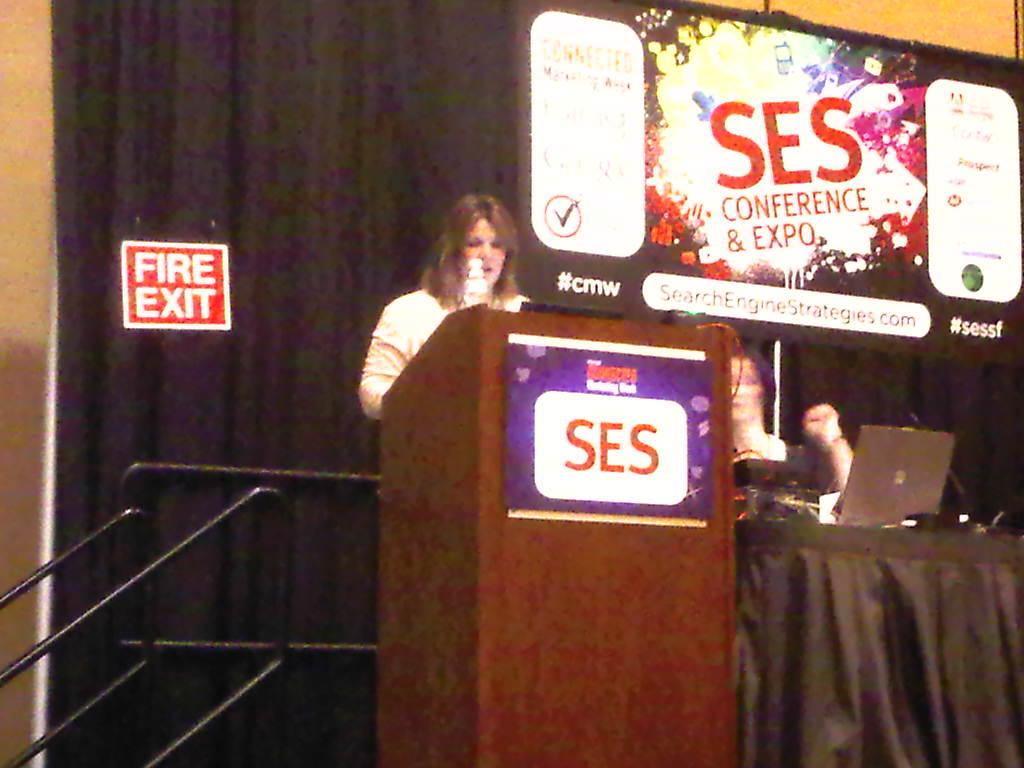In one or two sentences, can you explain what this image depicts? In this picture there is a lady who is standing in the center of the image in front of a wooden desk and there is a staircase on the left side of the image, there is a table on the right side of the image, on which there is a laptop and there is a another lady in front of the image, there is a poster on the right side of the image. 